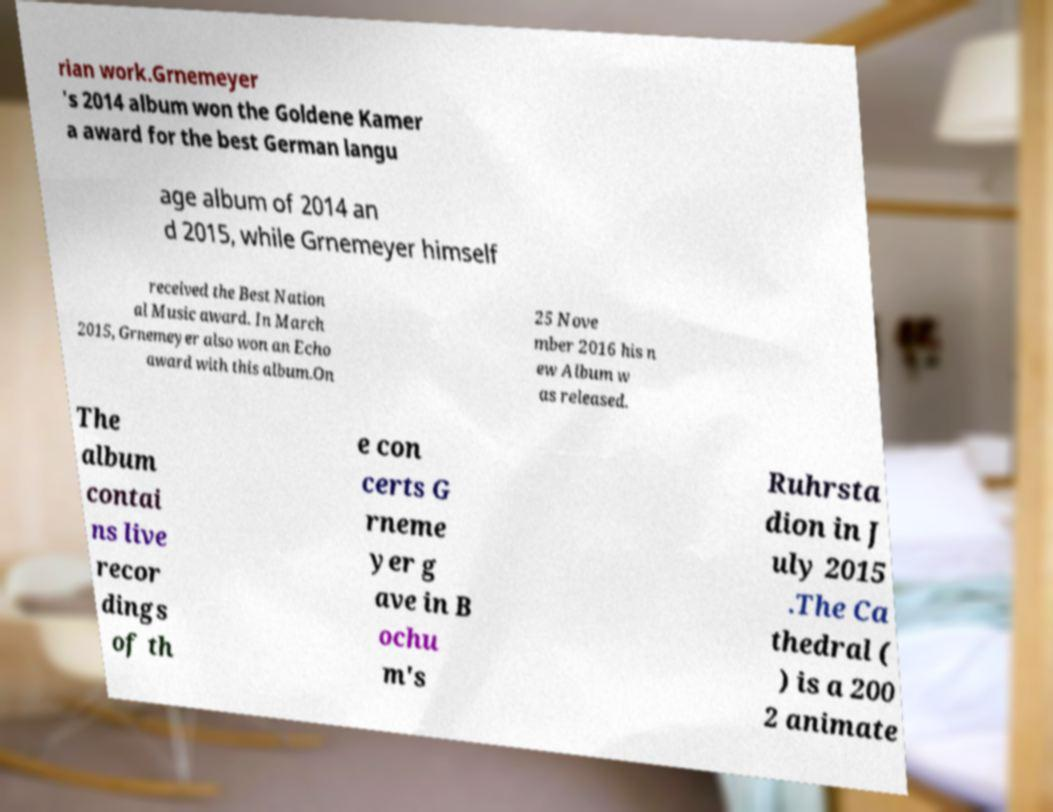For documentation purposes, I need the text within this image transcribed. Could you provide that? rian work.Grnemeyer 's 2014 album won the Goldene Kamer a award for the best German langu age album of 2014 an d 2015, while Grnemeyer himself received the Best Nation al Music award. In March 2015, Grnemeyer also won an Echo award with this album.On 25 Nove mber 2016 his n ew Album w as released. The album contai ns live recor dings of th e con certs G rneme yer g ave in B ochu m's Ruhrsta dion in J uly 2015 .The Ca thedral ( ) is a 200 2 animate 